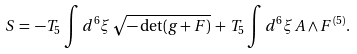Convert formula to latex. <formula><loc_0><loc_0><loc_500><loc_500>S \, = \, - T _ { 5 } \, \int d ^ { 6 } \xi \, \sqrt { - \det ( g + F ) } \, + \, T _ { 5 } \int d ^ { 6 } \xi \, A \wedge F ^ { ( 5 ) } .</formula> 